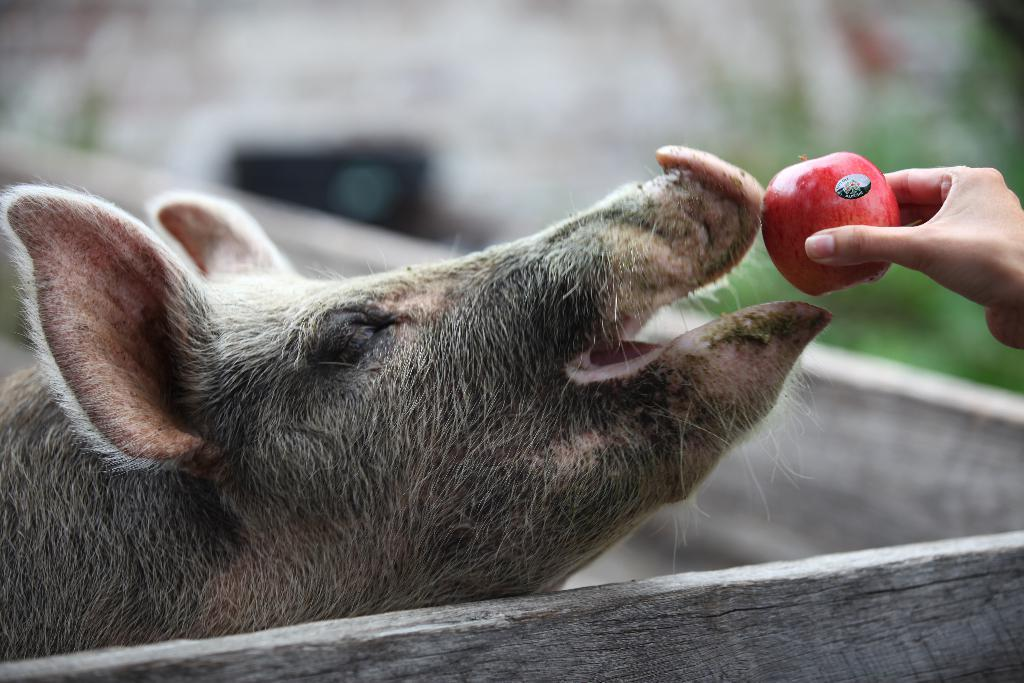What animal is present in the image? There is a pig in the image. What type of enclosure is around the pig? There is a wooden wall around the pig. What object is being held by a hand in the image? The hand is holding an apple in the image. How would you describe the background of the image? The background of the image is blurred. What type of recess is visible in the front of the pig? There is no recess visible in the front of the pig; the image only shows a pig, a wooden wall, a hand holding an apple, and a blurred background. 